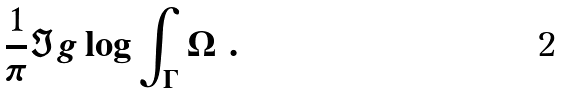<formula> <loc_0><loc_0><loc_500><loc_500>\frac { 1 } { \pi } \Im g \log \int _ { \Gamma } \Omega \ .</formula> 